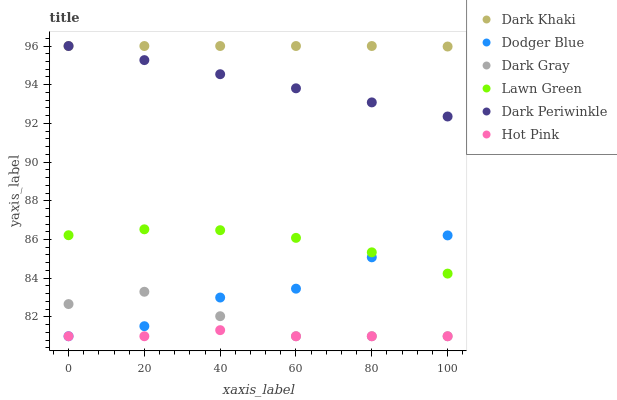Does Hot Pink have the minimum area under the curve?
Answer yes or no. Yes. Does Dark Khaki have the maximum area under the curve?
Answer yes or no. Yes. Does Lawn Green have the minimum area under the curve?
Answer yes or no. No. Does Lawn Green have the maximum area under the curve?
Answer yes or no. No. Is Dark Periwinkle the smoothest?
Answer yes or no. Yes. Is Dodger Blue the roughest?
Answer yes or no. Yes. Is Lawn Green the smoothest?
Answer yes or no. No. Is Lawn Green the roughest?
Answer yes or no. No. Does Dark Gray have the lowest value?
Answer yes or no. Yes. Does Lawn Green have the lowest value?
Answer yes or no. No. Does Dark Periwinkle have the highest value?
Answer yes or no. Yes. Does Lawn Green have the highest value?
Answer yes or no. No. Is Hot Pink less than Dark Periwinkle?
Answer yes or no. Yes. Is Dark Periwinkle greater than Hot Pink?
Answer yes or no. Yes. Does Dark Periwinkle intersect Dark Khaki?
Answer yes or no. Yes. Is Dark Periwinkle less than Dark Khaki?
Answer yes or no. No. Is Dark Periwinkle greater than Dark Khaki?
Answer yes or no. No. Does Hot Pink intersect Dark Periwinkle?
Answer yes or no. No. 